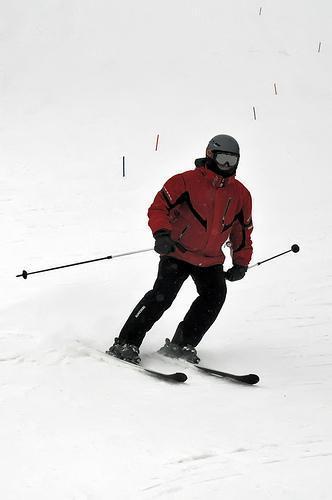How many people skiing?
Give a very brief answer. 1. 